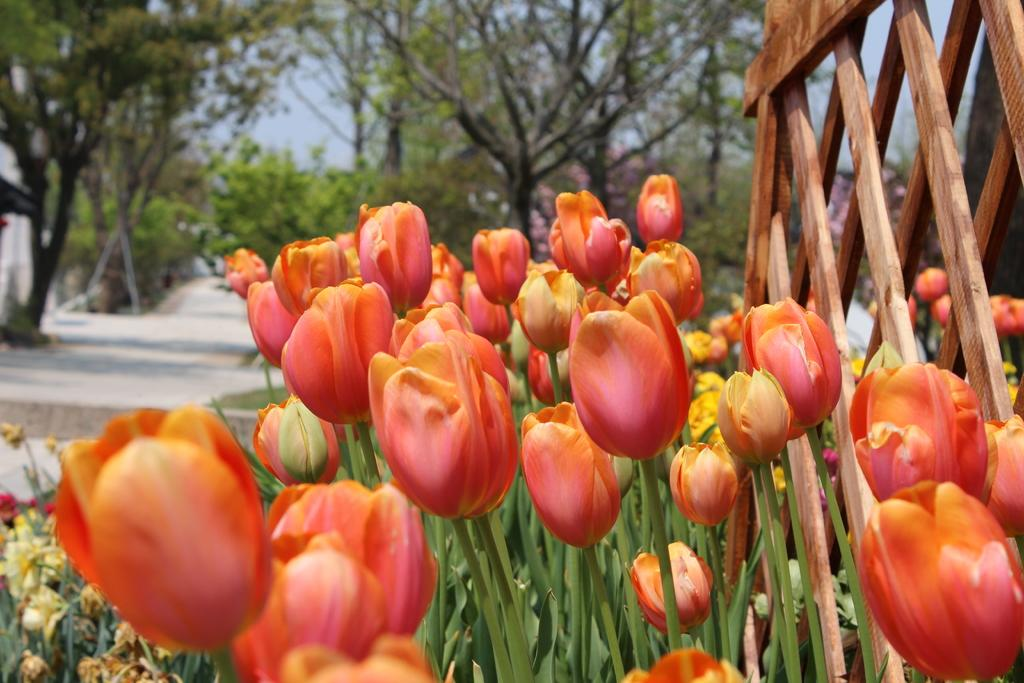What type of flowers can be seen in the image? There are tulip flowers in the image. What else is present in the image besides the flowers? There is a path and trees visible in the image. What can be seen in the background of the image? The sky is visible in the background of the image. What type of account is being discussed in the image? There is no account being discussed in the image; it features tulip flowers, a path, trees, and the sky. Can you hear the voice of the person who took the picture in the image? There is no voice present in the image, as it is a still photograph. 